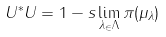Convert formula to latex. <formula><loc_0><loc_0><loc_500><loc_500>U ^ { * } U = 1 - s \lim _ { \lambda _ { \in } \Lambda } \pi ( \mu _ { \lambda } )</formula> 